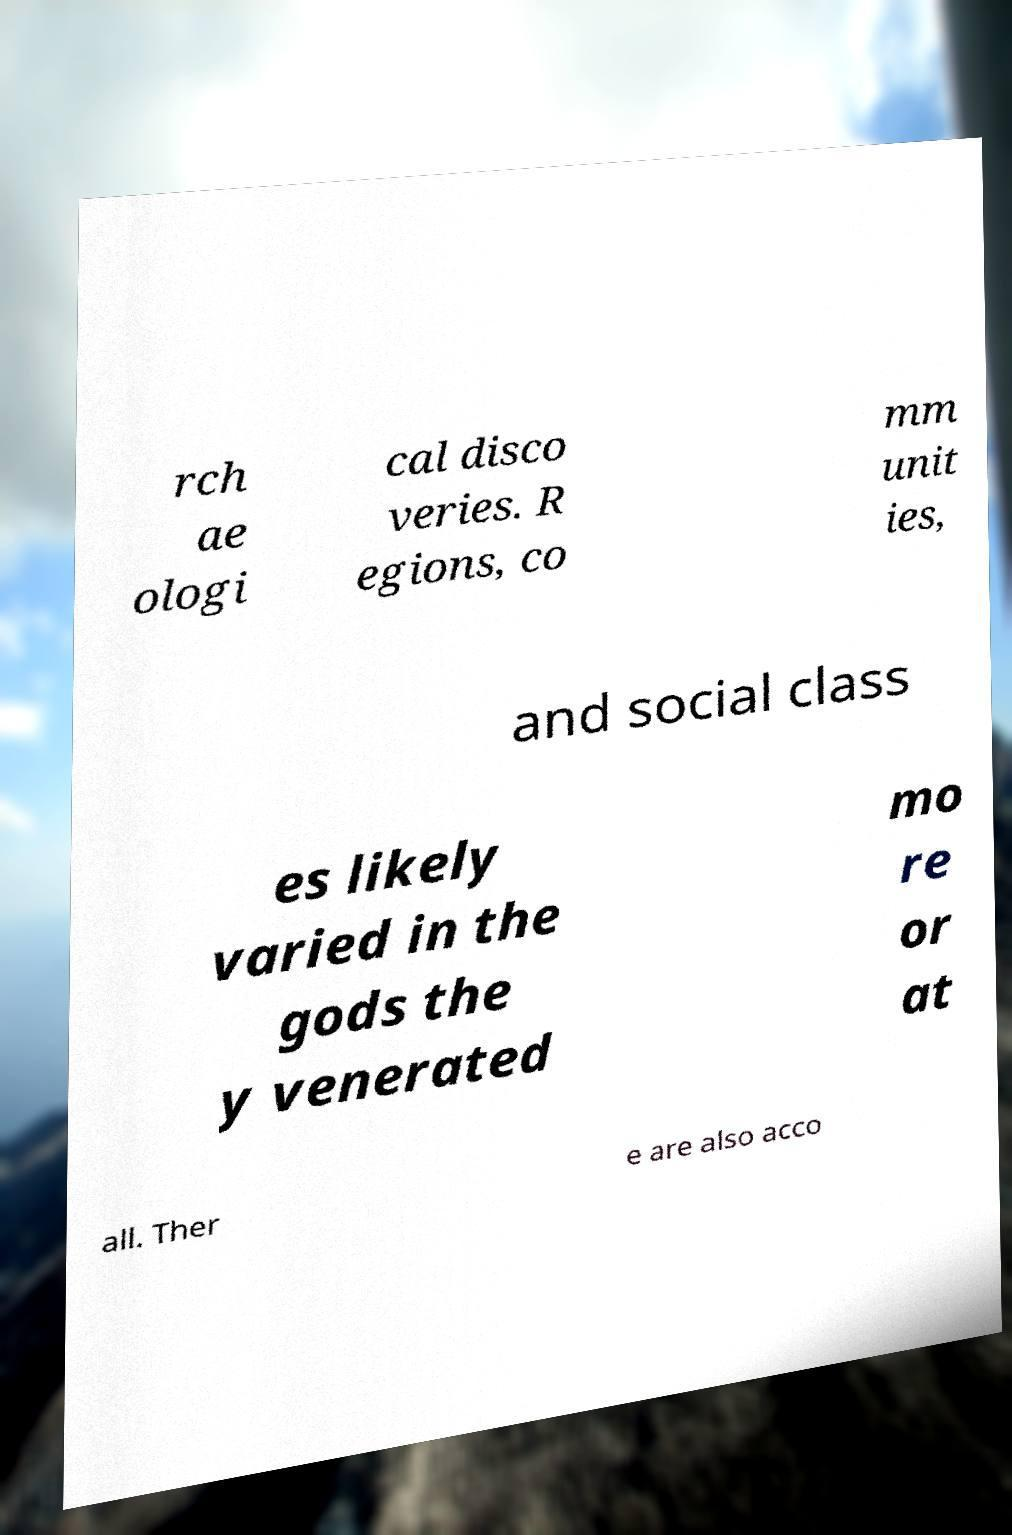Could you extract and type out the text from this image? rch ae ologi cal disco veries. R egions, co mm unit ies, and social class es likely varied in the gods the y venerated mo re or at all. Ther e are also acco 